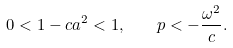Convert formula to latex. <formula><loc_0><loc_0><loc_500><loc_500>0 < 1 - c a ^ { 2 } < 1 , \quad p < - \frac { \omega ^ { 2 } } { c } .</formula> 